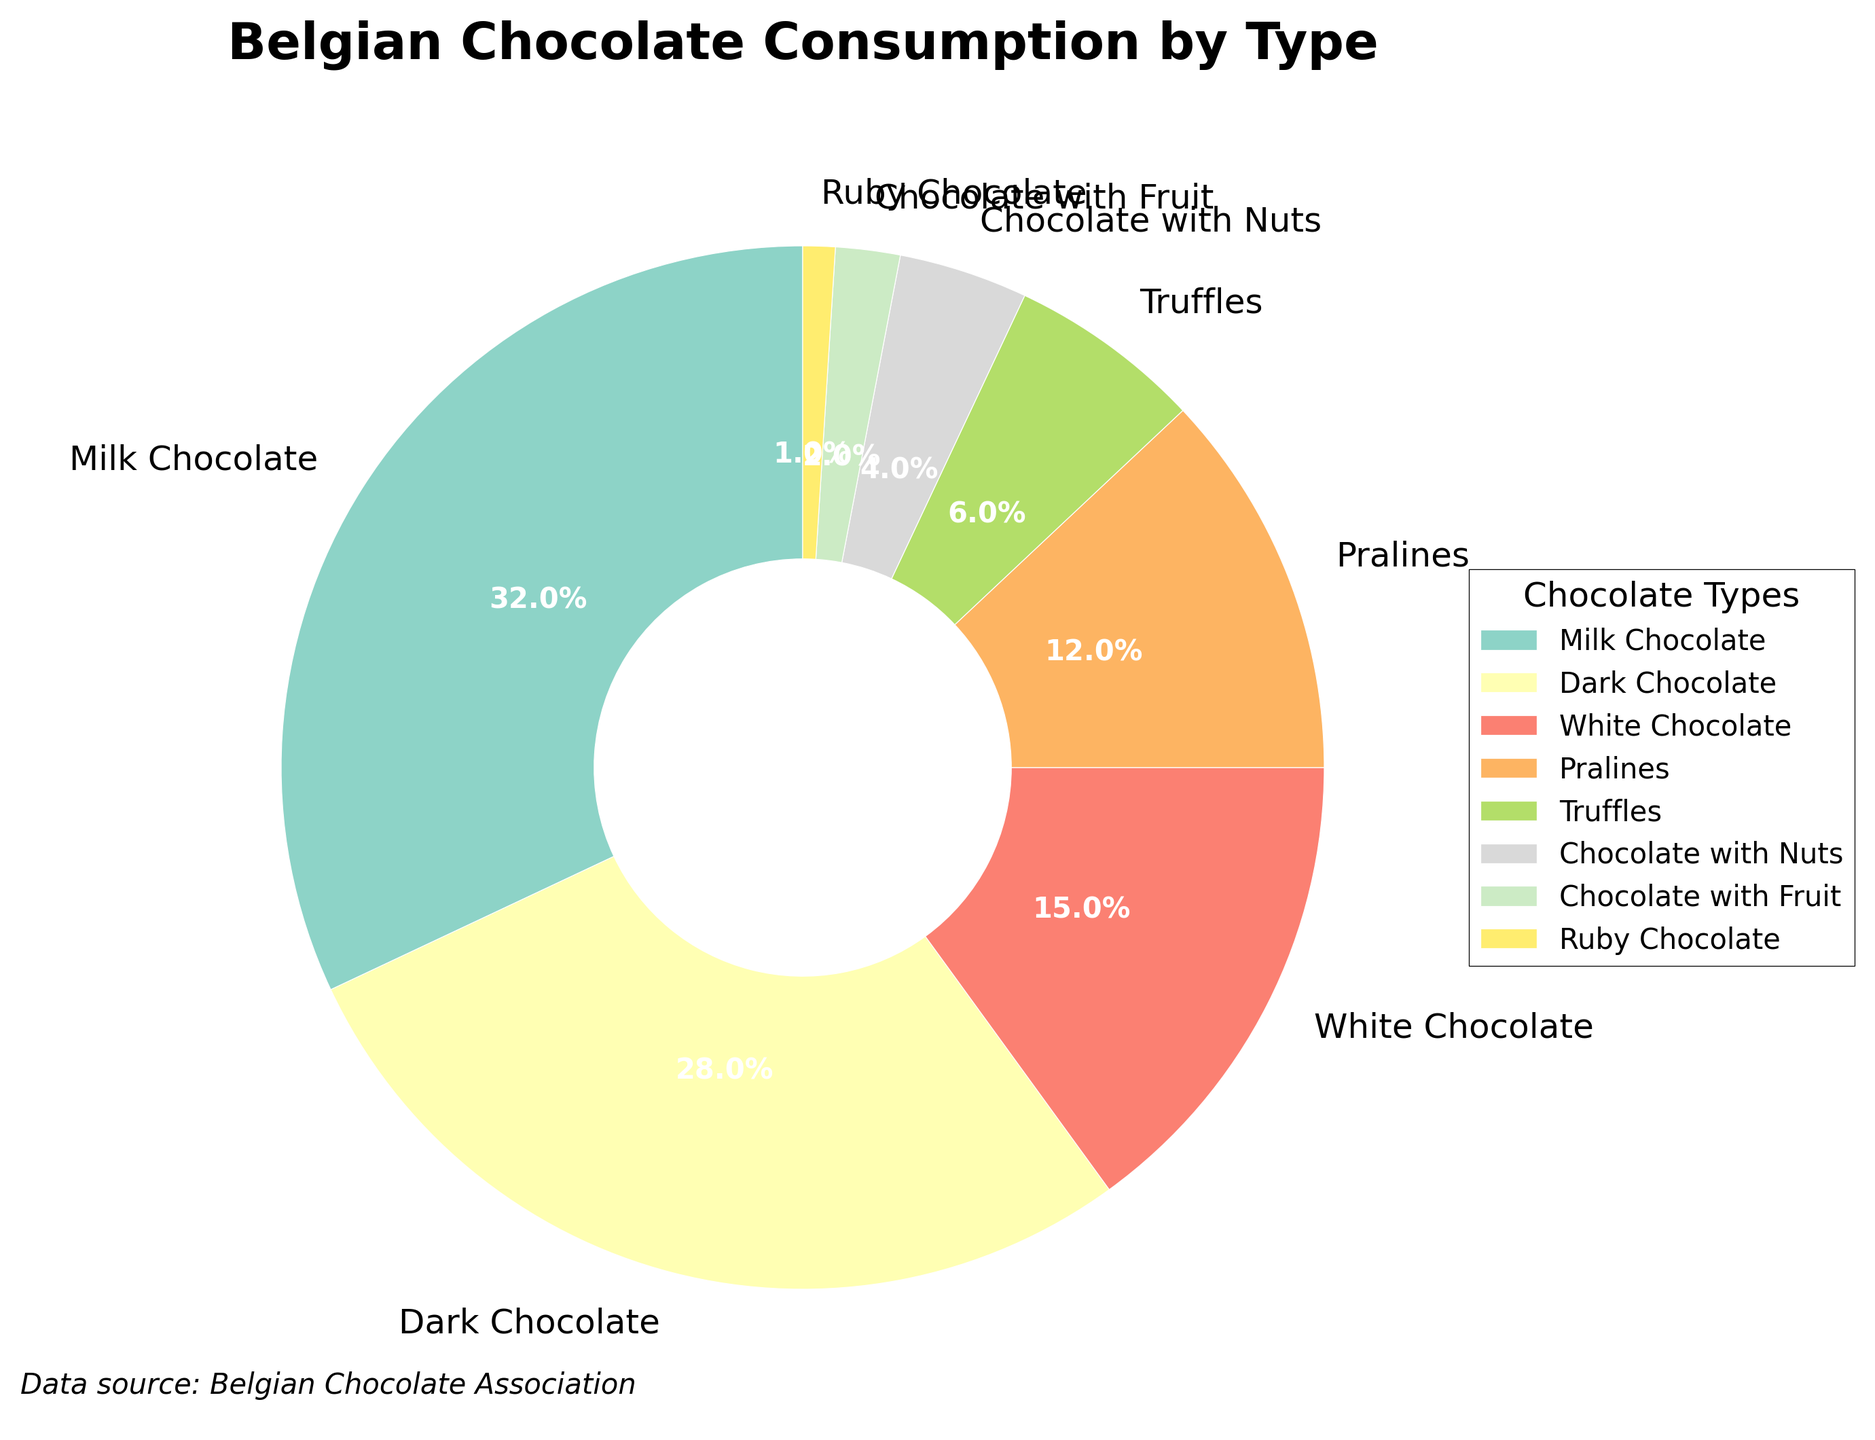What percentage of chocolate consumption do Milk Chocolate and Dark Chocolate account for combined? Sum the percentages of Milk Chocolate (32%) and Dark Chocolate (28%). 32 + 28 = 60
Answer: 60% Which type of chocolate has a smaller percentage of consumption, Chocolate with Nuts or Chocolate with Fruit? Compare the percentages of Chocolate with Nuts (4%) and Chocolate with Fruit (2%). 2 is less than 4
Answer: Chocolate with Fruit Is the consumption of White Chocolate higher than that of Pralines? White Chocolate is 15%, while Pralines are 12%. 15 is greater than 12.
Answer: Yes What is the total percentage of consumption for Truffles, Chocolate with Nuts, Chocolate with Fruit, and Ruby Chocolate? Add the percentages of Truffles (6%), Chocolate with Nuts (4%), Chocolate with Fruit (2%), and Ruby Chocolate (1%). 6 + 4 + 2 + 1 = 13
Answer: 13% Which type of chocolate has the largest wedge in the pie chart? The largest wedge is labeled Milk Chocolate and has a percentage of 32%.
Answer: Milk Chocolate What’s the difference in consumption percentage between the two most consumed types of chocolates? The two most consumed types are Milk Chocolate (32%) and Dark Chocolate (28%). The difference is 32 - 28 = 4
Answer: 4% Which type of chocolate is represented by the color furthest to the top of the pie chart? Look for the segment closest to the start angle of 90 degrees.
Answer: Milk Chocolate How does the consumption of Pralines compare to Truffles? Pralines have 12%, and Truffles have 6%. 12 is greater than 6.
Answer: Pralines are more consumed What's the combined percentage of all types of chocolate consumption shown in the pie chart? Sum the percentages of all listed types: 32 + 28 + 15 + 12 + 6 + 4 + 2 + 1 = 100
Answer: 100% If you combined the least consumed type with Ruby Chocolate, what would the new wedge's percentage be, and would it still be the smallest? The least consumed type besides Ruby Chocolate is Chocolate with Fruit (2%). Adding 2% to Ruby Chocolate's 1%, we get 3%. Compare this with the next smallest percentage (Chocolate with Nuts, 4%).
Answer: The new percentage is 3%, and it would still be the smallest 